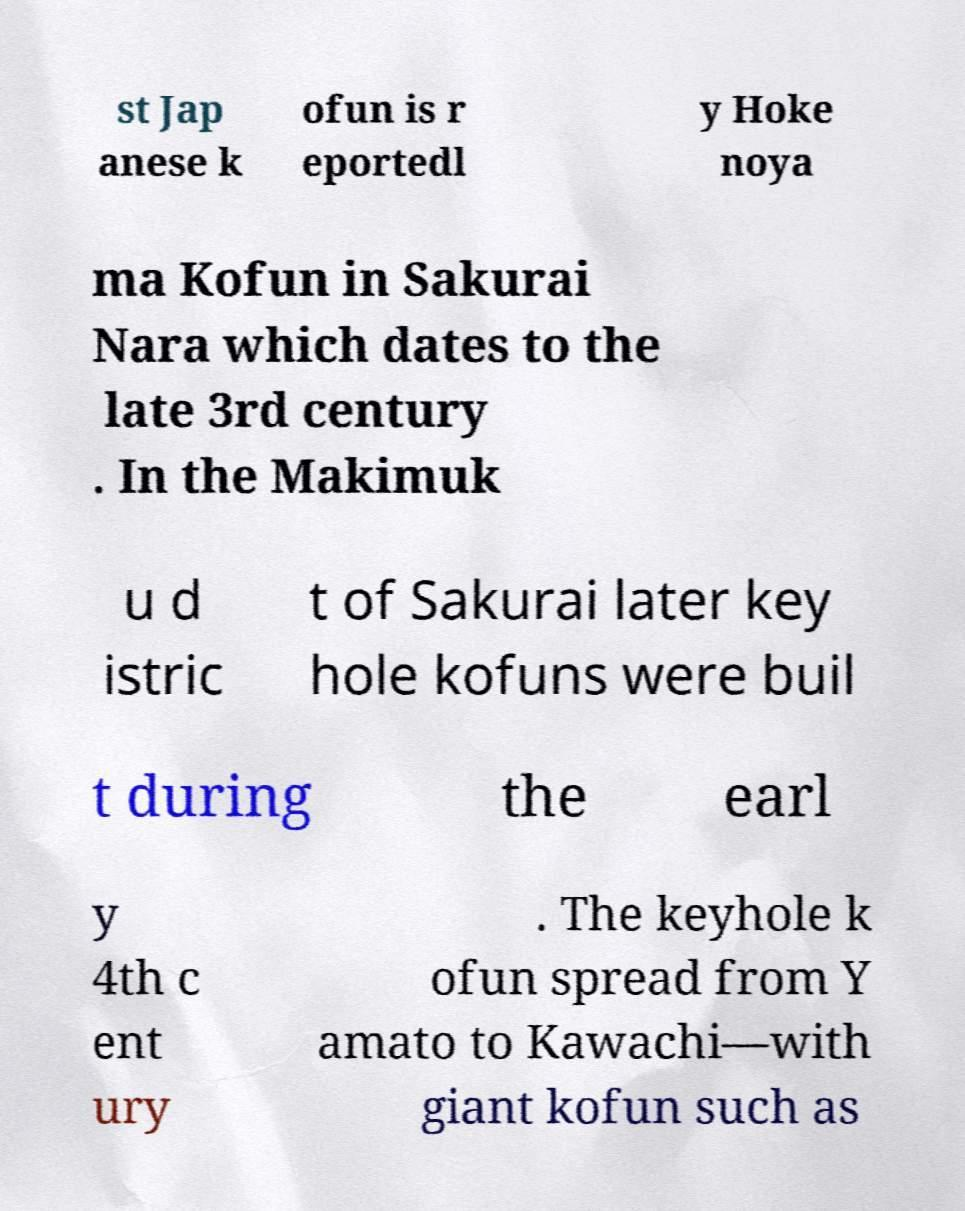Can you accurately transcribe the text from the provided image for me? st Jap anese k ofun is r eportedl y Hoke noya ma Kofun in Sakurai Nara which dates to the late 3rd century . In the Makimuk u d istric t of Sakurai later key hole kofuns were buil t during the earl y 4th c ent ury . The keyhole k ofun spread from Y amato to Kawachi—with giant kofun such as 